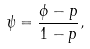Convert formula to latex. <formula><loc_0><loc_0><loc_500><loc_500>\psi = \frac { \phi - p } { 1 - p } ,</formula> 